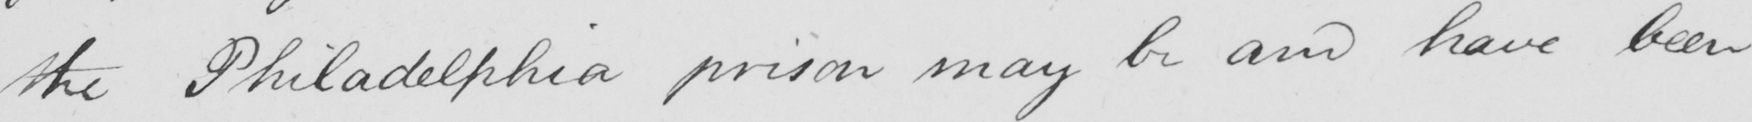What text is written in this handwritten line? the Philadelphia prison may be and have been 